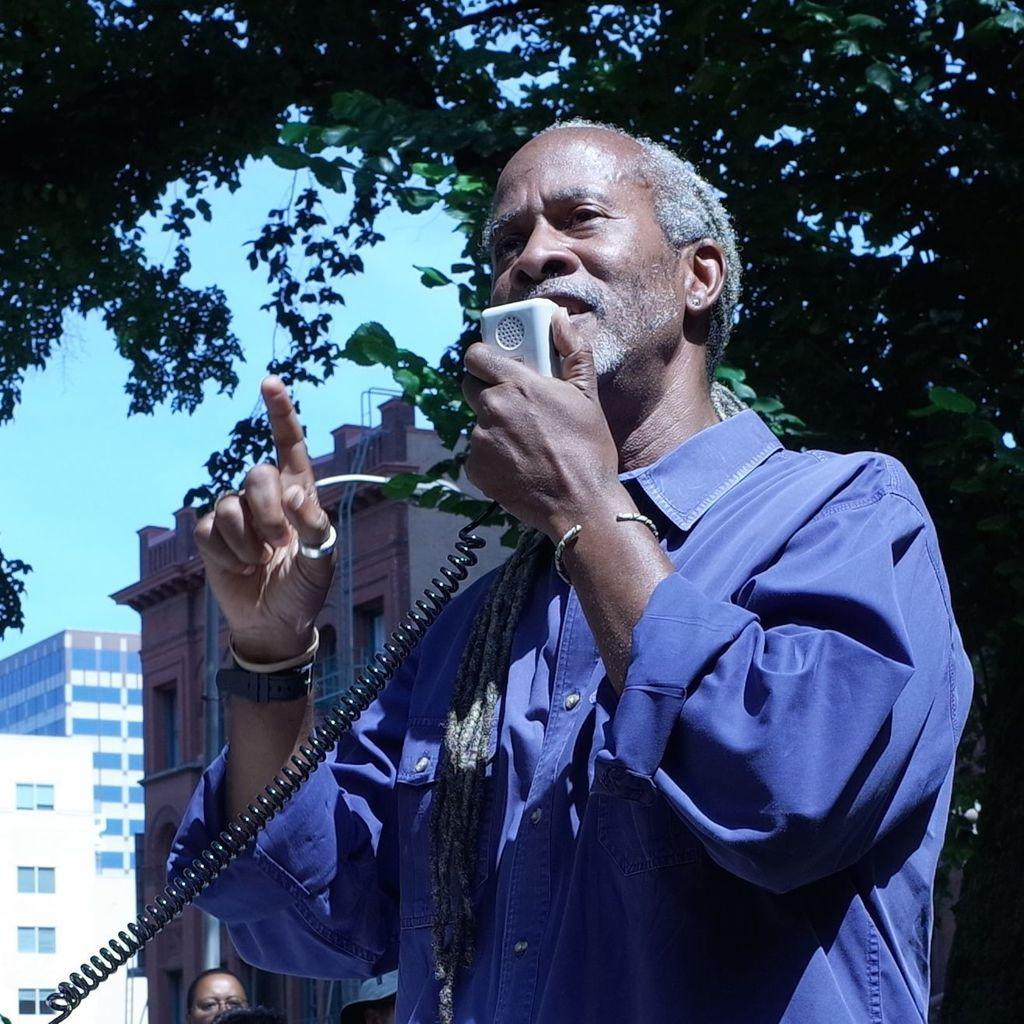In one or two sentences, can you explain what this image depicts? This picture shows a man standing and speaking with the help of hand walkie talkie and we see few buildings and couple of trees 